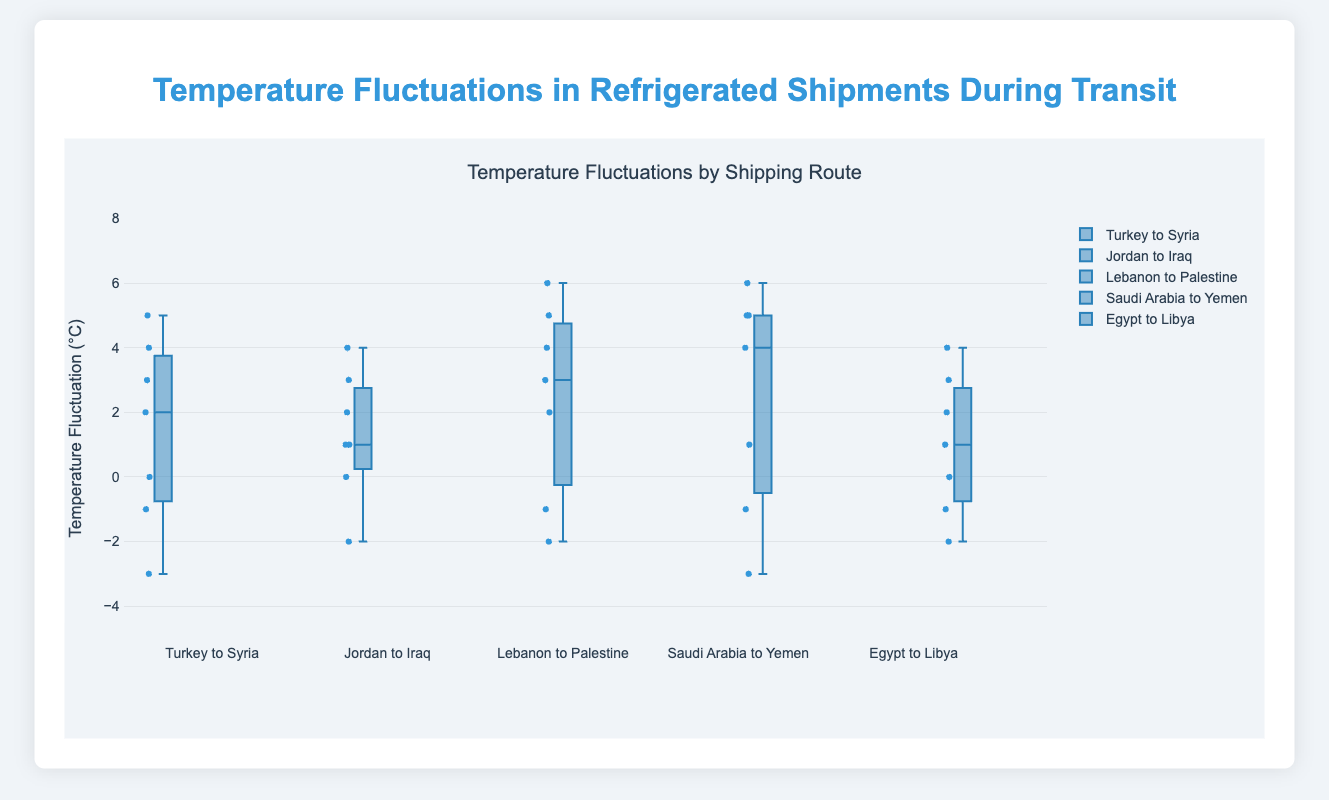What is the title of the chart? The title of the chart is usually displayed at the top. For this chart, it reads "Temperature Fluctuations by Shipping Route."
Answer: Temperature Fluctuations by Shipping Route What is the range of the y-axis? The range of the y-axis can be observed from the labels along the y-axis. The y-axis ranges from -5°C to 8°C.
Answer: -5°C to 8°C Which shipment route has the highest maximum temperature fluctuation? The highest maximum temperature fluctuation can be determined by identifying the longest whisker at the top of the boxes. The route from Saudi Arabia to Yemen has the highest temperature fluctuation of 6°C.
Answer: Saudi Arabia to Yemen What is the median temperature fluctuation for the shipment route "Jordan to Iraq"? The median is indicated by the line inside each box. For the route "Jordan to Iraq," the median temperature fluctuation is at 2°C.
Answer: 2°C Compare the interquartile ranges (IQR) of the "Turkey to Syria" and "Saudi Arabia to Yemen" routes. Which is larger? The IQR is the range between the first quartile (Q1) and the third quartile (Q3). For "Turkey to Syria", Q1 is about -1°C and Q3 is about 4°C, making the IQR approximately 5°C. For "Saudi Arabia to Yemen", Q1 is about 1°C and Q3 is about 5°C, making the IQR approximately 4°C. "Turkey to Syria" has a larger IQR.
Answer: Turkey to Syria What is the minimum temperature fluctuation for the shipment route "Lebanon to Palestine"? The minimum temperature fluctuation is indicated by the bottom whisker of the box. For the route "Lebanon to Palestine," the minimum temperature fluctuation is -2°C.
Answer: -2°C Which route has the smallest range of temperature fluctuations? The range is the difference between the maximum and minimum values. By examining the lengths of the whiskers, the "Egypt to Libya" route appears to have the smallest range from -2°C to 4°C, making it 6°C overall.
Answer: Egypt to Libya On which route is the temperature fluctuation's median closer to the lower quartile (Q1)? The relative position of the median line inside the box can show this. For the route "Egypt to Libya," the median is at 2°C, while Q1 is just slightly below it at 1°C, making the median much closer to Q1.
Answer: Egypt to Libya Which route shows an outlier in temperature fluctuations? Outliers are usually individual points outside the whiskers. The "Lebanon to Palestine" route shows an outlier at 6°C.
Answer: Lebanon to Palestine Which shipment route shows the most symmetrical distribution of temperature fluctuations? A symmetrical distribution will have the median line near the center of the box with equally long whiskers. The "Jordan to Iraq" route seems to be the most symmetrical around the median.
Answer: Jordan to Iraq 